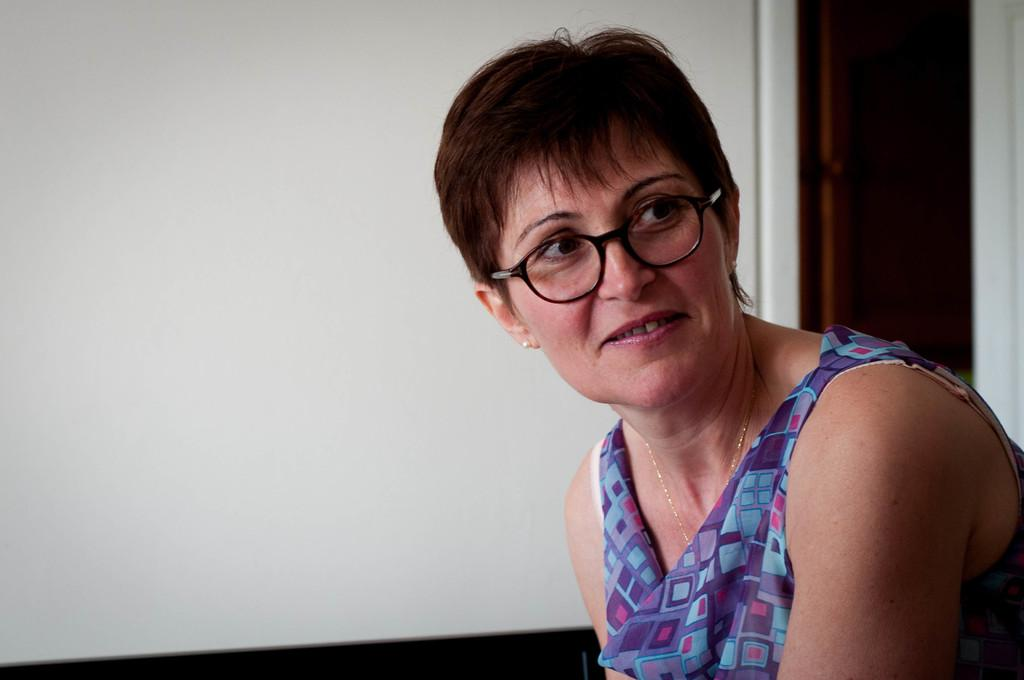What is the main subject of the image? The main subject of the image is a woman. Can you describe the setting or environment in the image? There is a wall beside the woman in the image. Can you see an owl perched on the wall in the image? There is no owl present in the image. What type of polish is the woman applying to her nails in the image? The image does not show the woman applying any polish to her nails. 